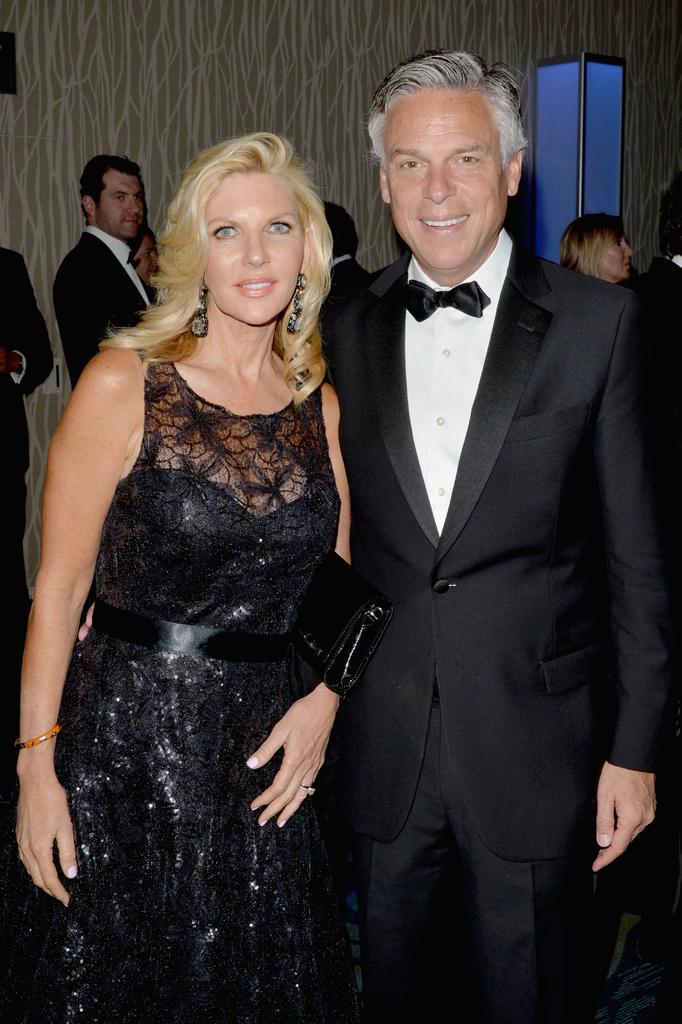Please provide a concise description of this image. In this image, I can see a group of people on the floor. In the background, I can see a door and a wall. This image taken, maybe in a hall. 